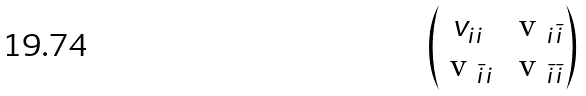<formula> <loc_0><loc_0><loc_500><loc_500>\begin{pmatrix} v _ { i i } & $ v $ _ { i \bar { i } } \\ $ v $ _ { \bar { i } i } & $ v $ _ { \bar { i } \bar { i } } \\ \end{pmatrix}</formula> 